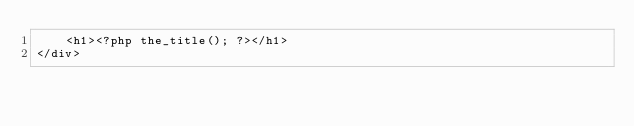Convert code to text. <code><loc_0><loc_0><loc_500><loc_500><_PHP_>	<h1><?php the_title(); ?></h1>
</div></code> 